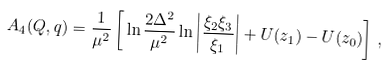<formula> <loc_0><loc_0><loc_500><loc_500>A _ { 4 } ( Q , q ) = \frac { 1 } { \mu ^ { 2 } } \left [ \, \ln \frac { 2 \Delta ^ { 2 } } { \mu ^ { 2 } } \ln \left | \frac { \xi _ { 2 } \xi _ { 3 } } { \xi _ { 1 } } \right | + U ( z _ { 1 } ) - U ( z _ { 0 } ) \right ] \, ,</formula> 